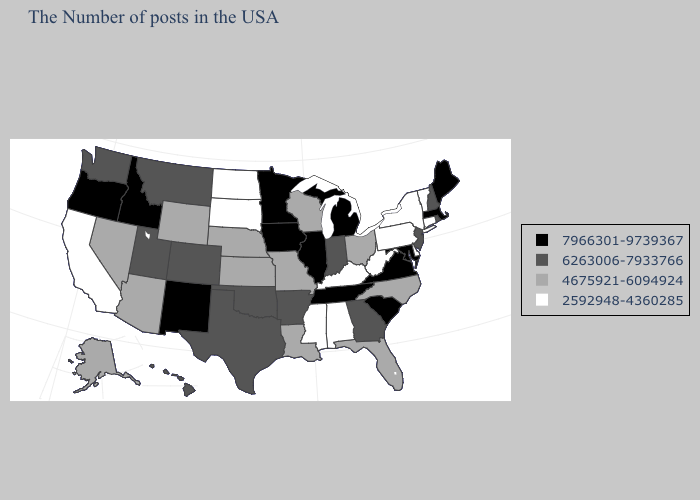Among the states that border Arkansas , which have the lowest value?
Answer briefly. Mississippi. Which states have the lowest value in the Northeast?
Answer briefly. Vermont, Connecticut, New York, Pennsylvania. Name the states that have a value in the range 2592948-4360285?
Write a very short answer. Vermont, Connecticut, New York, Delaware, Pennsylvania, West Virginia, Kentucky, Alabama, Mississippi, South Dakota, North Dakota, California. Name the states that have a value in the range 7966301-9739367?
Answer briefly. Maine, Massachusetts, Maryland, Virginia, South Carolina, Michigan, Tennessee, Illinois, Minnesota, Iowa, New Mexico, Idaho, Oregon. What is the highest value in the MidWest ?
Quick response, please. 7966301-9739367. Does Alaska have the same value as West Virginia?
Short answer required. No. Among the states that border Pennsylvania , which have the highest value?
Quick response, please. Maryland. Among the states that border Indiana , which have the highest value?
Quick response, please. Michigan, Illinois. Does Ohio have the highest value in the MidWest?
Write a very short answer. No. What is the highest value in the USA?
Write a very short answer. 7966301-9739367. Does Georgia have a higher value than Vermont?
Keep it brief. Yes. Does Michigan have the lowest value in the MidWest?
Quick response, please. No. Name the states that have a value in the range 6263006-7933766?
Keep it brief. Rhode Island, New Hampshire, New Jersey, Georgia, Indiana, Arkansas, Oklahoma, Texas, Colorado, Utah, Montana, Washington, Hawaii. Name the states that have a value in the range 6263006-7933766?
Concise answer only. Rhode Island, New Hampshire, New Jersey, Georgia, Indiana, Arkansas, Oklahoma, Texas, Colorado, Utah, Montana, Washington, Hawaii. Name the states that have a value in the range 7966301-9739367?
Keep it brief. Maine, Massachusetts, Maryland, Virginia, South Carolina, Michigan, Tennessee, Illinois, Minnesota, Iowa, New Mexico, Idaho, Oregon. 